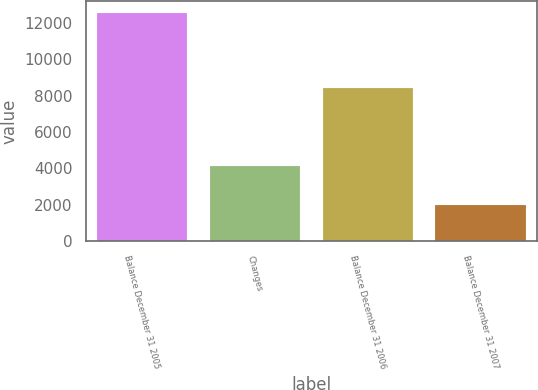Convert chart. <chart><loc_0><loc_0><loc_500><loc_500><bar_chart><fcel>Balance December 31 2005<fcel>Changes<fcel>Balance December 31 2006<fcel>Balance December 31 2007<nl><fcel>12553<fcel>4155<fcel>8398<fcel>1975<nl></chart> 